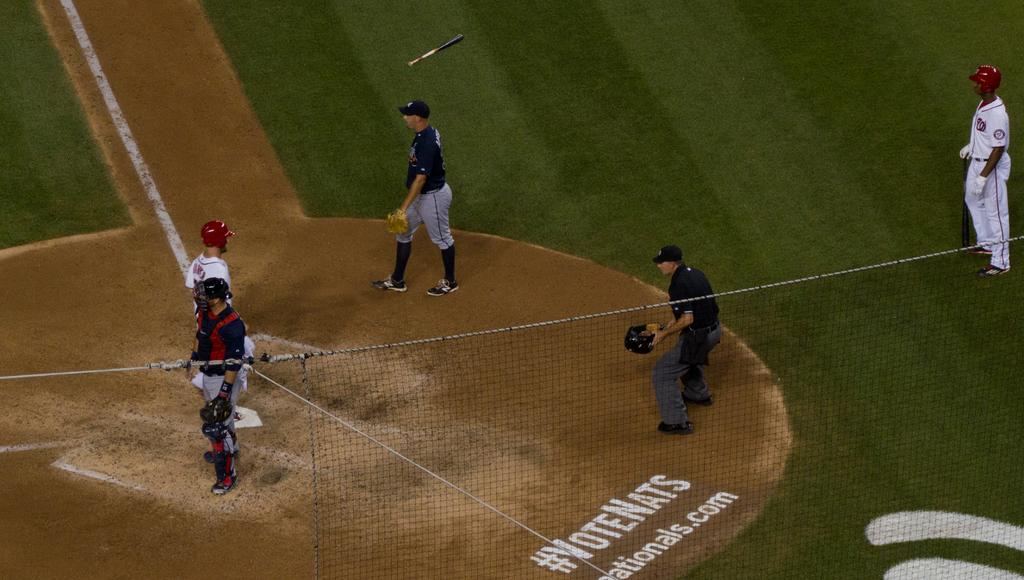<image>
Render a clear and concise summary of the photo. People playing baseball on a field that says "VoteNats". 